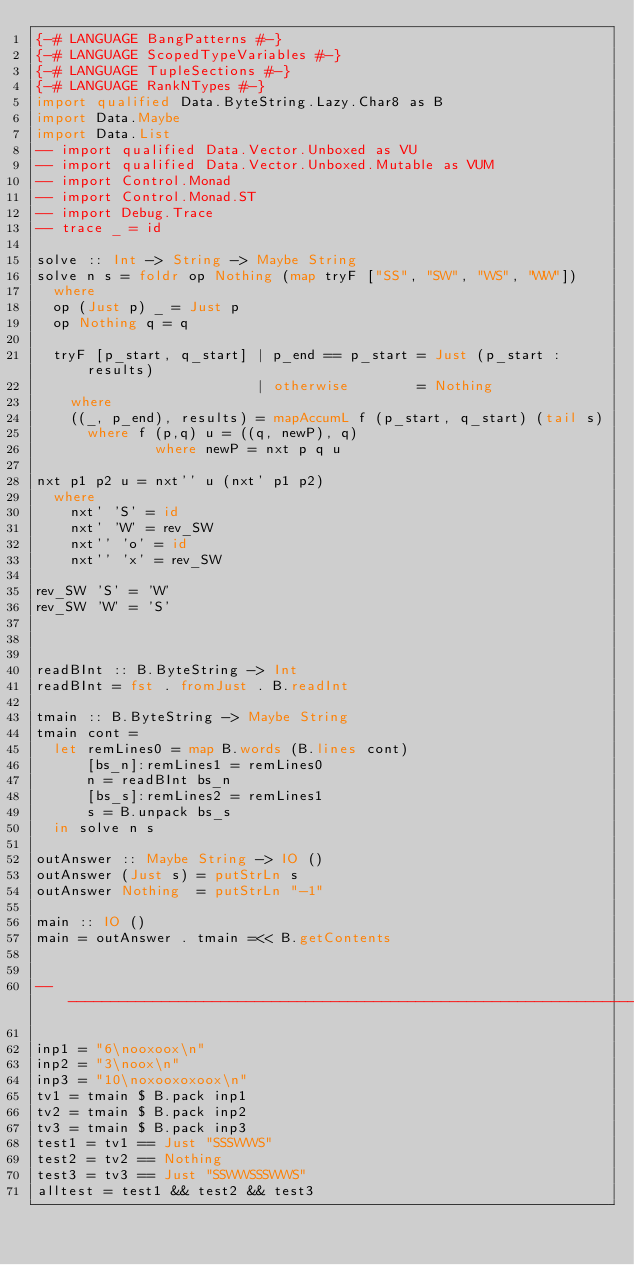<code> <loc_0><loc_0><loc_500><loc_500><_Haskell_>{-# LANGUAGE BangPatterns #-}
{-# LANGUAGE ScopedTypeVariables #-}
{-# LANGUAGE TupleSections #-}
{-# LANGUAGE RankNTypes #-}
import qualified Data.ByteString.Lazy.Char8 as B
import Data.Maybe
import Data.List
-- import qualified Data.Vector.Unboxed as VU
-- import qualified Data.Vector.Unboxed.Mutable as VUM
-- import Control.Monad
-- import Control.Monad.ST
-- import Debug.Trace
-- trace _ = id

solve :: Int -> String -> Maybe String
solve n s = foldr op Nothing (map tryF ["SS", "SW", "WS", "WW"])
  where
  op (Just p) _ = Just p
  op Nothing q = q

  tryF [p_start, q_start] | p_end == p_start = Just (p_start : results)
                          | otherwise        = Nothing
    where
    ((_, p_end), results) = mapAccumL f (p_start, q_start) (tail s)
      where f (p,q) u = ((q, newP), q)
              where newP = nxt p q u

nxt p1 p2 u = nxt'' u (nxt' p1 p2)
  where
    nxt' 'S' = id
    nxt' 'W' = rev_SW
    nxt'' 'o' = id
    nxt'' 'x' = rev_SW

rev_SW 'S' = 'W'
rev_SW 'W' = 'S'



readBInt :: B.ByteString -> Int
readBInt = fst . fromJust . B.readInt

tmain :: B.ByteString -> Maybe String
tmain cont =
  let remLines0 = map B.words (B.lines cont)
      [bs_n]:remLines1 = remLines0
      n = readBInt bs_n
      [bs_s]:remLines2 = remLines1
      s = B.unpack bs_s
  in solve n s

outAnswer :: Maybe String -> IO ()
outAnswer (Just s) = putStrLn s
outAnswer Nothing  = putStrLn "-1"

main :: IO ()
main = outAnswer . tmain =<< B.getContents


-------------------------------------------------------------------------------

inp1 = "6\nooxoox\n"
inp2 = "3\noox\n"
inp3 = "10\noxooxoxoox\n"
tv1 = tmain $ B.pack inp1
tv2 = tmain $ B.pack inp2
tv3 = tmain $ B.pack inp3
test1 = tv1 == Just "SSSWWS"
test2 = tv2 == Nothing
test3 = tv3 == Just "SSWWSSSWWS"
alltest = test1 && test2 && test3

</code> 